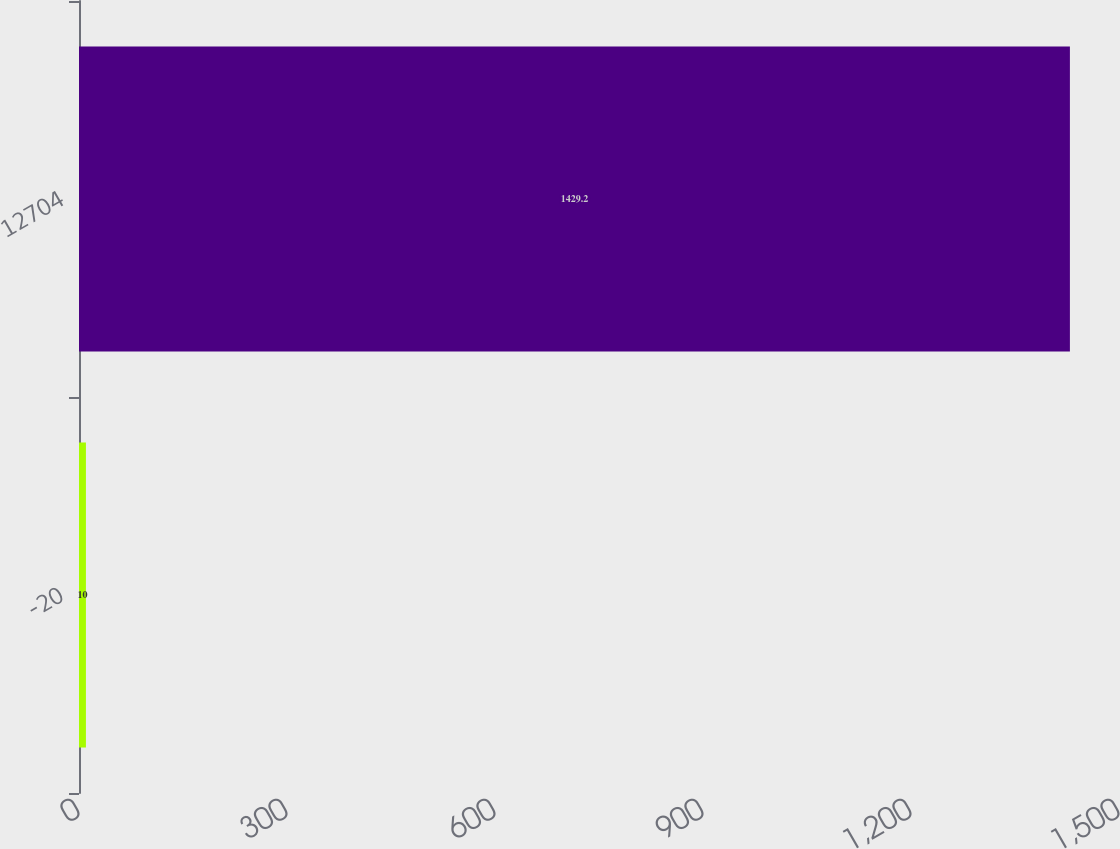Convert chart. <chart><loc_0><loc_0><loc_500><loc_500><bar_chart><fcel>-20<fcel>12704<nl><fcel>10<fcel>1429.2<nl></chart> 